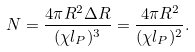<formula> <loc_0><loc_0><loc_500><loc_500>N = \frac { 4 \pi R ^ { 2 } \Delta R } { ( \chi l _ { P } ) ^ { 3 } } = \frac { 4 \pi R ^ { 2 } } { ( \chi l _ { P } ) ^ { 2 } } .</formula> 